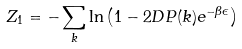Convert formula to latex. <formula><loc_0><loc_0><loc_500><loc_500>Z _ { 1 } = - \sum _ { k } \ln \left ( 1 - 2 D P ( { k } ) e ^ { - \beta \epsilon } \right )</formula> 